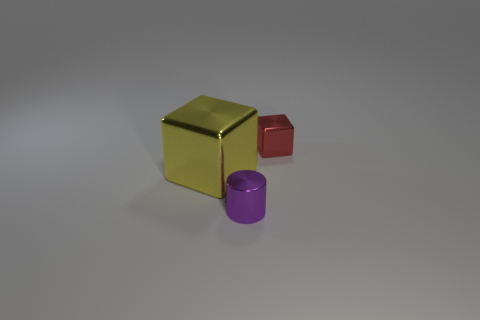What is the color of the tiny metal cube?
Provide a succinct answer. Red. What number of other things are there of the same size as the yellow metal thing?
Make the answer very short. 0. The small thing left of the small object behind the yellow thing is made of what material?
Provide a short and direct response. Metal. There is a yellow block; is its size the same as the metallic block on the right side of the big yellow block?
Your answer should be compact. No. Are there any other large objects that have the same color as the big metal thing?
Provide a succinct answer. No. What number of tiny objects are purple objects or yellow metal things?
Your response must be concise. 1. What number of blue rubber things are there?
Give a very brief answer. 0. What material is the tiny object behind the tiny purple cylinder?
Offer a very short reply. Metal. Are there any small cubes in front of the tiny metallic block?
Keep it short and to the point. No. Is the purple metallic object the same size as the yellow metallic object?
Give a very brief answer. No. 